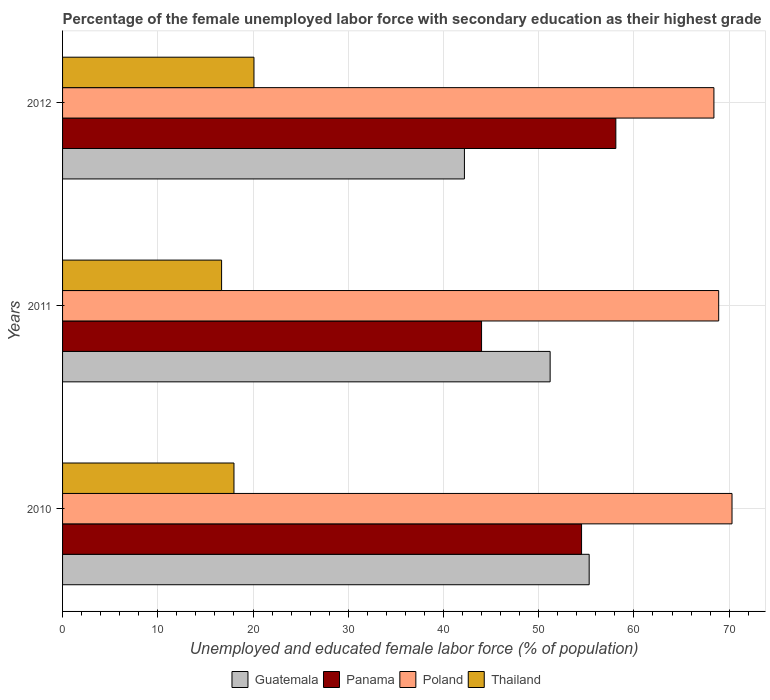How many groups of bars are there?
Offer a terse response. 3. Are the number of bars per tick equal to the number of legend labels?
Offer a terse response. Yes. How many bars are there on the 3rd tick from the top?
Provide a short and direct response. 4. How many bars are there on the 1st tick from the bottom?
Offer a terse response. 4. In how many cases, is the number of bars for a given year not equal to the number of legend labels?
Give a very brief answer. 0. What is the percentage of the unemployed female labor force with secondary education in Panama in 2010?
Your response must be concise. 54.5. Across all years, what is the maximum percentage of the unemployed female labor force with secondary education in Poland?
Your answer should be compact. 70.3. Across all years, what is the minimum percentage of the unemployed female labor force with secondary education in Poland?
Provide a short and direct response. 68.4. In which year was the percentage of the unemployed female labor force with secondary education in Guatemala maximum?
Your answer should be very brief. 2010. In which year was the percentage of the unemployed female labor force with secondary education in Guatemala minimum?
Offer a terse response. 2012. What is the total percentage of the unemployed female labor force with secondary education in Thailand in the graph?
Ensure brevity in your answer.  54.8. What is the difference between the percentage of the unemployed female labor force with secondary education in Poland in 2010 and that in 2012?
Give a very brief answer. 1.9. What is the difference between the percentage of the unemployed female labor force with secondary education in Guatemala in 2011 and the percentage of the unemployed female labor force with secondary education in Panama in 2012?
Keep it short and to the point. -6.9. What is the average percentage of the unemployed female labor force with secondary education in Poland per year?
Give a very brief answer. 69.2. In the year 2011, what is the difference between the percentage of the unemployed female labor force with secondary education in Thailand and percentage of the unemployed female labor force with secondary education in Panama?
Offer a very short reply. -27.3. What is the ratio of the percentage of the unemployed female labor force with secondary education in Panama in 2010 to that in 2011?
Give a very brief answer. 1.24. What is the difference between the highest and the second highest percentage of the unemployed female labor force with secondary education in Thailand?
Offer a terse response. 2.1. What is the difference between the highest and the lowest percentage of the unemployed female labor force with secondary education in Panama?
Offer a very short reply. 14.1. In how many years, is the percentage of the unemployed female labor force with secondary education in Thailand greater than the average percentage of the unemployed female labor force with secondary education in Thailand taken over all years?
Make the answer very short. 1. Is it the case that in every year, the sum of the percentage of the unemployed female labor force with secondary education in Panama and percentage of the unemployed female labor force with secondary education in Guatemala is greater than the sum of percentage of the unemployed female labor force with secondary education in Poland and percentage of the unemployed female labor force with secondary education in Thailand?
Give a very brief answer. No. What does the 3rd bar from the top in 2010 represents?
Make the answer very short. Panama. How many bars are there?
Provide a short and direct response. 12. Are all the bars in the graph horizontal?
Your answer should be compact. Yes. How many years are there in the graph?
Offer a terse response. 3. Are the values on the major ticks of X-axis written in scientific E-notation?
Keep it short and to the point. No. Where does the legend appear in the graph?
Give a very brief answer. Bottom center. How many legend labels are there?
Ensure brevity in your answer.  4. What is the title of the graph?
Offer a very short reply. Percentage of the female unemployed labor force with secondary education as their highest grade. Does "Zambia" appear as one of the legend labels in the graph?
Give a very brief answer. No. What is the label or title of the X-axis?
Offer a terse response. Unemployed and educated female labor force (% of population). What is the label or title of the Y-axis?
Offer a terse response. Years. What is the Unemployed and educated female labor force (% of population) in Guatemala in 2010?
Your response must be concise. 55.3. What is the Unemployed and educated female labor force (% of population) of Panama in 2010?
Your answer should be compact. 54.5. What is the Unemployed and educated female labor force (% of population) of Poland in 2010?
Keep it short and to the point. 70.3. What is the Unemployed and educated female labor force (% of population) in Thailand in 2010?
Keep it short and to the point. 18. What is the Unemployed and educated female labor force (% of population) of Guatemala in 2011?
Provide a succinct answer. 51.2. What is the Unemployed and educated female labor force (% of population) of Poland in 2011?
Provide a succinct answer. 68.9. What is the Unemployed and educated female labor force (% of population) in Thailand in 2011?
Give a very brief answer. 16.7. What is the Unemployed and educated female labor force (% of population) in Guatemala in 2012?
Ensure brevity in your answer.  42.2. What is the Unemployed and educated female labor force (% of population) of Panama in 2012?
Provide a succinct answer. 58.1. What is the Unemployed and educated female labor force (% of population) of Poland in 2012?
Offer a terse response. 68.4. What is the Unemployed and educated female labor force (% of population) of Thailand in 2012?
Ensure brevity in your answer.  20.1. Across all years, what is the maximum Unemployed and educated female labor force (% of population) in Guatemala?
Offer a terse response. 55.3. Across all years, what is the maximum Unemployed and educated female labor force (% of population) in Panama?
Offer a very short reply. 58.1. Across all years, what is the maximum Unemployed and educated female labor force (% of population) of Poland?
Your response must be concise. 70.3. Across all years, what is the maximum Unemployed and educated female labor force (% of population) in Thailand?
Give a very brief answer. 20.1. Across all years, what is the minimum Unemployed and educated female labor force (% of population) of Guatemala?
Your answer should be compact. 42.2. Across all years, what is the minimum Unemployed and educated female labor force (% of population) in Panama?
Offer a terse response. 44. Across all years, what is the minimum Unemployed and educated female labor force (% of population) in Poland?
Ensure brevity in your answer.  68.4. Across all years, what is the minimum Unemployed and educated female labor force (% of population) in Thailand?
Offer a terse response. 16.7. What is the total Unemployed and educated female labor force (% of population) of Guatemala in the graph?
Provide a short and direct response. 148.7. What is the total Unemployed and educated female labor force (% of population) of Panama in the graph?
Your answer should be compact. 156.6. What is the total Unemployed and educated female labor force (% of population) of Poland in the graph?
Your answer should be very brief. 207.6. What is the total Unemployed and educated female labor force (% of population) of Thailand in the graph?
Offer a terse response. 54.8. What is the difference between the Unemployed and educated female labor force (% of population) of Guatemala in 2010 and that in 2011?
Keep it short and to the point. 4.1. What is the difference between the Unemployed and educated female labor force (% of population) in Guatemala in 2010 and that in 2012?
Give a very brief answer. 13.1. What is the difference between the Unemployed and educated female labor force (% of population) in Panama in 2010 and that in 2012?
Offer a terse response. -3.6. What is the difference between the Unemployed and educated female labor force (% of population) in Guatemala in 2011 and that in 2012?
Give a very brief answer. 9. What is the difference between the Unemployed and educated female labor force (% of population) of Panama in 2011 and that in 2012?
Give a very brief answer. -14.1. What is the difference between the Unemployed and educated female labor force (% of population) of Guatemala in 2010 and the Unemployed and educated female labor force (% of population) of Panama in 2011?
Give a very brief answer. 11.3. What is the difference between the Unemployed and educated female labor force (% of population) in Guatemala in 2010 and the Unemployed and educated female labor force (% of population) in Thailand in 2011?
Keep it short and to the point. 38.6. What is the difference between the Unemployed and educated female labor force (% of population) in Panama in 2010 and the Unemployed and educated female labor force (% of population) in Poland in 2011?
Provide a short and direct response. -14.4. What is the difference between the Unemployed and educated female labor force (% of population) of Panama in 2010 and the Unemployed and educated female labor force (% of population) of Thailand in 2011?
Provide a succinct answer. 37.8. What is the difference between the Unemployed and educated female labor force (% of population) in Poland in 2010 and the Unemployed and educated female labor force (% of population) in Thailand in 2011?
Your answer should be compact. 53.6. What is the difference between the Unemployed and educated female labor force (% of population) of Guatemala in 2010 and the Unemployed and educated female labor force (% of population) of Panama in 2012?
Ensure brevity in your answer.  -2.8. What is the difference between the Unemployed and educated female labor force (% of population) of Guatemala in 2010 and the Unemployed and educated female labor force (% of population) of Poland in 2012?
Offer a very short reply. -13.1. What is the difference between the Unemployed and educated female labor force (% of population) in Guatemala in 2010 and the Unemployed and educated female labor force (% of population) in Thailand in 2012?
Offer a very short reply. 35.2. What is the difference between the Unemployed and educated female labor force (% of population) in Panama in 2010 and the Unemployed and educated female labor force (% of population) in Thailand in 2012?
Your answer should be very brief. 34.4. What is the difference between the Unemployed and educated female labor force (% of population) in Poland in 2010 and the Unemployed and educated female labor force (% of population) in Thailand in 2012?
Keep it short and to the point. 50.2. What is the difference between the Unemployed and educated female labor force (% of population) in Guatemala in 2011 and the Unemployed and educated female labor force (% of population) in Panama in 2012?
Your response must be concise. -6.9. What is the difference between the Unemployed and educated female labor force (% of population) in Guatemala in 2011 and the Unemployed and educated female labor force (% of population) in Poland in 2012?
Keep it short and to the point. -17.2. What is the difference between the Unemployed and educated female labor force (% of population) in Guatemala in 2011 and the Unemployed and educated female labor force (% of population) in Thailand in 2012?
Provide a succinct answer. 31.1. What is the difference between the Unemployed and educated female labor force (% of population) in Panama in 2011 and the Unemployed and educated female labor force (% of population) in Poland in 2012?
Provide a short and direct response. -24.4. What is the difference between the Unemployed and educated female labor force (% of population) of Panama in 2011 and the Unemployed and educated female labor force (% of population) of Thailand in 2012?
Offer a terse response. 23.9. What is the difference between the Unemployed and educated female labor force (% of population) of Poland in 2011 and the Unemployed and educated female labor force (% of population) of Thailand in 2012?
Give a very brief answer. 48.8. What is the average Unemployed and educated female labor force (% of population) of Guatemala per year?
Your response must be concise. 49.57. What is the average Unemployed and educated female labor force (% of population) in Panama per year?
Ensure brevity in your answer.  52.2. What is the average Unemployed and educated female labor force (% of population) of Poland per year?
Ensure brevity in your answer.  69.2. What is the average Unemployed and educated female labor force (% of population) of Thailand per year?
Give a very brief answer. 18.27. In the year 2010, what is the difference between the Unemployed and educated female labor force (% of population) of Guatemala and Unemployed and educated female labor force (% of population) of Thailand?
Ensure brevity in your answer.  37.3. In the year 2010, what is the difference between the Unemployed and educated female labor force (% of population) of Panama and Unemployed and educated female labor force (% of population) of Poland?
Make the answer very short. -15.8. In the year 2010, what is the difference between the Unemployed and educated female labor force (% of population) in Panama and Unemployed and educated female labor force (% of population) in Thailand?
Your answer should be very brief. 36.5. In the year 2010, what is the difference between the Unemployed and educated female labor force (% of population) of Poland and Unemployed and educated female labor force (% of population) of Thailand?
Offer a very short reply. 52.3. In the year 2011, what is the difference between the Unemployed and educated female labor force (% of population) in Guatemala and Unemployed and educated female labor force (% of population) in Panama?
Your answer should be very brief. 7.2. In the year 2011, what is the difference between the Unemployed and educated female labor force (% of population) of Guatemala and Unemployed and educated female labor force (% of population) of Poland?
Provide a succinct answer. -17.7. In the year 2011, what is the difference between the Unemployed and educated female labor force (% of population) of Guatemala and Unemployed and educated female labor force (% of population) of Thailand?
Provide a succinct answer. 34.5. In the year 2011, what is the difference between the Unemployed and educated female labor force (% of population) in Panama and Unemployed and educated female labor force (% of population) in Poland?
Your answer should be very brief. -24.9. In the year 2011, what is the difference between the Unemployed and educated female labor force (% of population) in Panama and Unemployed and educated female labor force (% of population) in Thailand?
Offer a terse response. 27.3. In the year 2011, what is the difference between the Unemployed and educated female labor force (% of population) of Poland and Unemployed and educated female labor force (% of population) of Thailand?
Provide a succinct answer. 52.2. In the year 2012, what is the difference between the Unemployed and educated female labor force (% of population) in Guatemala and Unemployed and educated female labor force (% of population) in Panama?
Offer a very short reply. -15.9. In the year 2012, what is the difference between the Unemployed and educated female labor force (% of population) in Guatemala and Unemployed and educated female labor force (% of population) in Poland?
Your response must be concise. -26.2. In the year 2012, what is the difference between the Unemployed and educated female labor force (% of population) of Guatemala and Unemployed and educated female labor force (% of population) of Thailand?
Give a very brief answer. 22.1. In the year 2012, what is the difference between the Unemployed and educated female labor force (% of population) of Poland and Unemployed and educated female labor force (% of population) of Thailand?
Offer a terse response. 48.3. What is the ratio of the Unemployed and educated female labor force (% of population) in Guatemala in 2010 to that in 2011?
Keep it short and to the point. 1.08. What is the ratio of the Unemployed and educated female labor force (% of population) of Panama in 2010 to that in 2011?
Ensure brevity in your answer.  1.24. What is the ratio of the Unemployed and educated female labor force (% of population) in Poland in 2010 to that in 2011?
Offer a very short reply. 1.02. What is the ratio of the Unemployed and educated female labor force (% of population) in Thailand in 2010 to that in 2011?
Give a very brief answer. 1.08. What is the ratio of the Unemployed and educated female labor force (% of population) in Guatemala in 2010 to that in 2012?
Your response must be concise. 1.31. What is the ratio of the Unemployed and educated female labor force (% of population) in Panama in 2010 to that in 2012?
Keep it short and to the point. 0.94. What is the ratio of the Unemployed and educated female labor force (% of population) of Poland in 2010 to that in 2012?
Provide a short and direct response. 1.03. What is the ratio of the Unemployed and educated female labor force (% of population) in Thailand in 2010 to that in 2012?
Ensure brevity in your answer.  0.9. What is the ratio of the Unemployed and educated female labor force (% of population) in Guatemala in 2011 to that in 2012?
Offer a terse response. 1.21. What is the ratio of the Unemployed and educated female labor force (% of population) in Panama in 2011 to that in 2012?
Your response must be concise. 0.76. What is the ratio of the Unemployed and educated female labor force (% of population) in Poland in 2011 to that in 2012?
Provide a short and direct response. 1.01. What is the ratio of the Unemployed and educated female labor force (% of population) in Thailand in 2011 to that in 2012?
Your response must be concise. 0.83. What is the difference between the highest and the second highest Unemployed and educated female labor force (% of population) of Guatemala?
Your answer should be compact. 4.1. What is the difference between the highest and the second highest Unemployed and educated female labor force (% of population) in Poland?
Provide a succinct answer. 1.4. What is the difference between the highest and the lowest Unemployed and educated female labor force (% of population) in Poland?
Keep it short and to the point. 1.9. What is the difference between the highest and the lowest Unemployed and educated female labor force (% of population) of Thailand?
Provide a short and direct response. 3.4. 